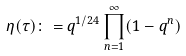Convert formula to latex. <formula><loc_0><loc_0><loc_500><loc_500>\eta ( \tau ) \colon = q ^ { 1 / 2 4 } \prod ^ { \infty } _ { n = 1 } ( 1 - q ^ { n } )</formula> 